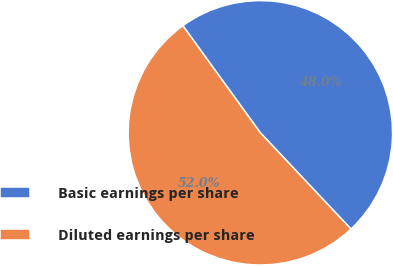Convert chart to OTSL. <chart><loc_0><loc_0><loc_500><loc_500><pie_chart><fcel>Basic earnings per share<fcel>Diluted earnings per share<nl><fcel>47.95%<fcel>52.05%<nl></chart> 